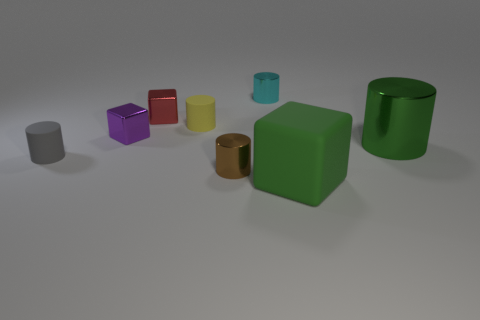Subtract 1 cylinders. How many cylinders are left? 4 Subtract all yellow cylinders. How many cylinders are left? 4 Subtract all yellow matte cylinders. How many cylinders are left? 4 Subtract all red cylinders. Subtract all red spheres. How many cylinders are left? 5 Add 2 purple cubes. How many objects exist? 10 Subtract all cylinders. How many objects are left? 3 Subtract 0 purple spheres. How many objects are left? 8 Subtract all red metal blocks. Subtract all large yellow metallic cylinders. How many objects are left? 7 Add 6 small blocks. How many small blocks are left? 8 Add 2 small rubber cylinders. How many small rubber cylinders exist? 4 